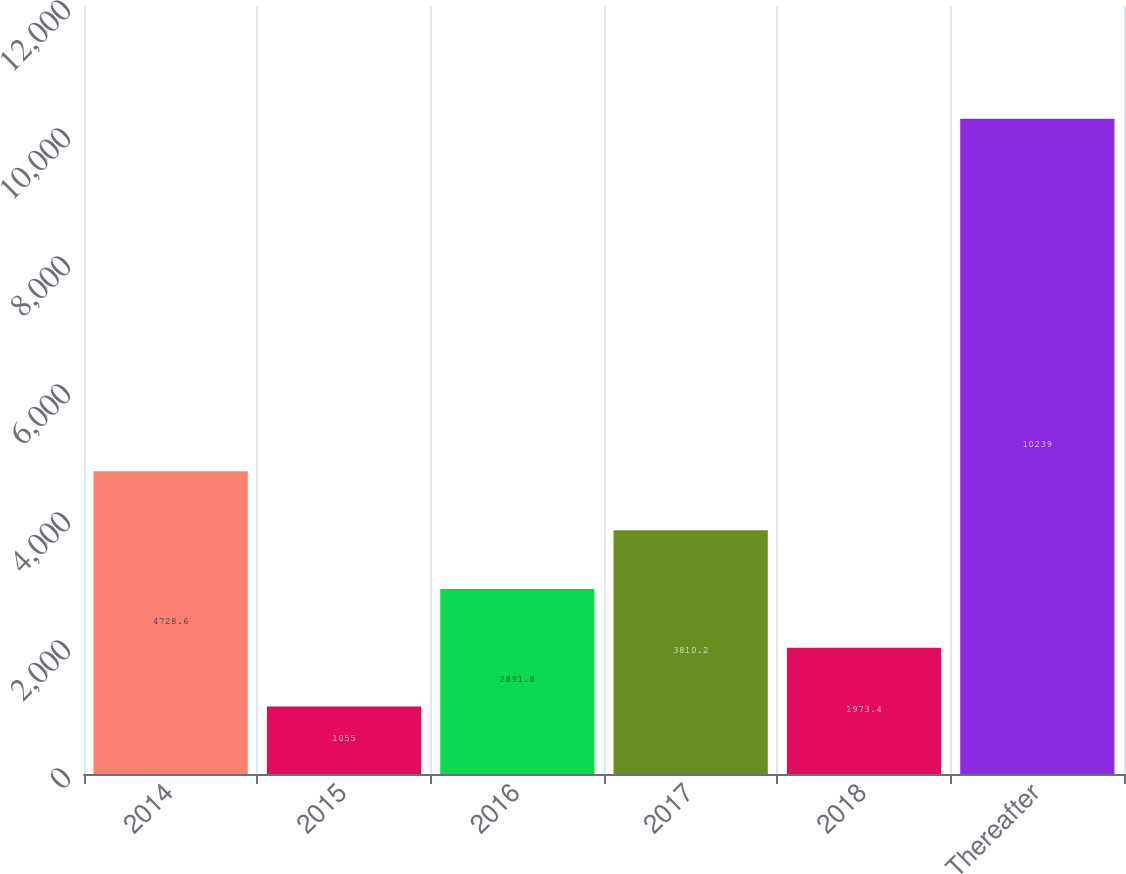Convert chart to OTSL. <chart><loc_0><loc_0><loc_500><loc_500><bar_chart><fcel>2014<fcel>2015<fcel>2016<fcel>2017<fcel>2018<fcel>Thereafter<nl><fcel>4728.6<fcel>1055<fcel>2891.8<fcel>3810.2<fcel>1973.4<fcel>10239<nl></chart> 